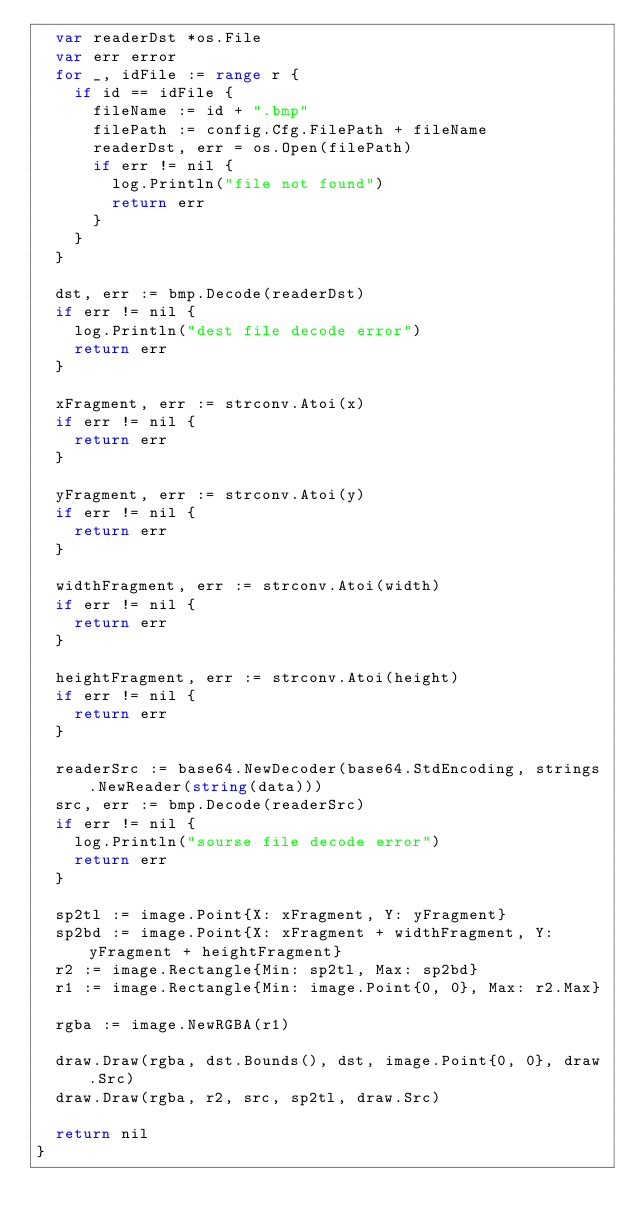Convert code to text. <code><loc_0><loc_0><loc_500><loc_500><_Go_>	var readerDst *os.File
	var err error
	for _, idFile := range r {
		if id == idFile {
			fileName := id + ".bmp"
			filePath := config.Cfg.FilePath + fileName
			readerDst, err = os.Open(filePath)
			if err != nil {
				log.Println("file not found")
				return err
			}
		}
	}

	dst, err := bmp.Decode(readerDst)
	if err != nil {
		log.Println("dest file decode error")
		return err
	}

	xFragment, err := strconv.Atoi(x)
	if err != nil {
		return err
	}

	yFragment, err := strconv.Atoi(y)
	if err != nil {
		return err
	}

	widthFragment, err := strconv.Atoi(width)
	if err != nil {
		return err
	}

	heightFragment, err := strconv.Atoi(height)
	if err != nil {
		return err
	}

	readerSrc := base64.NewDecoder(base64.StdEncoding, strings.NewReader(string(data)))
	src, err := bmp.Decode(readerSrc)
	if err != nil {
		log.Println("sourse file decode error")
		return err
	}

	sp2tl := image.Point{X: xFragment, Y: yFragment}
	sp2bd := image.Point{X: xFragment + widthFragment, Y: yFragment + heightFragment}
	r2 := image.Rectangle{Min: sp2tl, Max: sp2bd}
	r1 := image.Rectangle{Min: image.Point{0, 0}, Max: r2.Max}

	rgba := image.NewRGBA(r1)

	draw.Draw(rgba, dst.Bounds(), dst, image.Point{0, 0}, draw.Src)
	draw.Draw(rgba, r2, src, sp2tl, draw.Src)

	return nil
}
</code> 